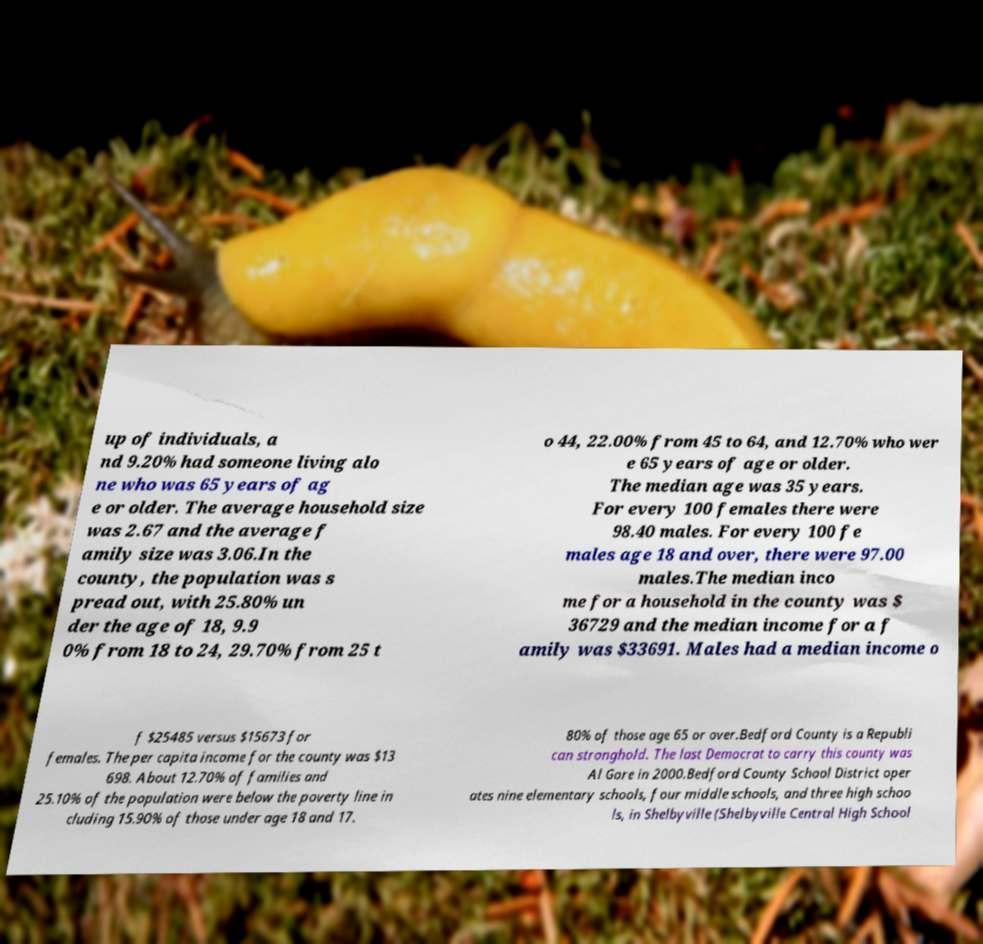There's text embedded in this image that I need extracted. Can you transcribe it verbatim? up of individuals, a nd 9.20% had someone living alo ne who was 65 years of ag e or older. The average household size was 2.67 and the average f amily size was 3.06.In the county, the population was s pread out, with 25.80% un der the age of 18, 9.9 0% from 18 to 24, 29.70% from 25 t o 44, 22.00% from 45 to 64, and 12.70% who wer e 65 years of age or older. The median age was 35 years. For every 100 females there were 98.40 males. For every 100 fe males age 18 and over, there were 97.00 males.The median inco me for a household in the county was $ 36729 and the median income for a f amily was $33691. Males had a median income o f $25485 versus $15673 for females. The per capita income for the county was $13 698. About 12.70% of families and 25.10% of the population were below the poverty line in cluding 15.90% of those under age 18 and 17. 80% of those age 65 or over.Bedford County is a Republi can stronghold. The last Democrat to carry this county was Al Gore in 2000.Bedford County School District oper ates nine elementary schools, four middle schools, and three high schoo ls, in Shelbyville (Shelbyville Central High School 